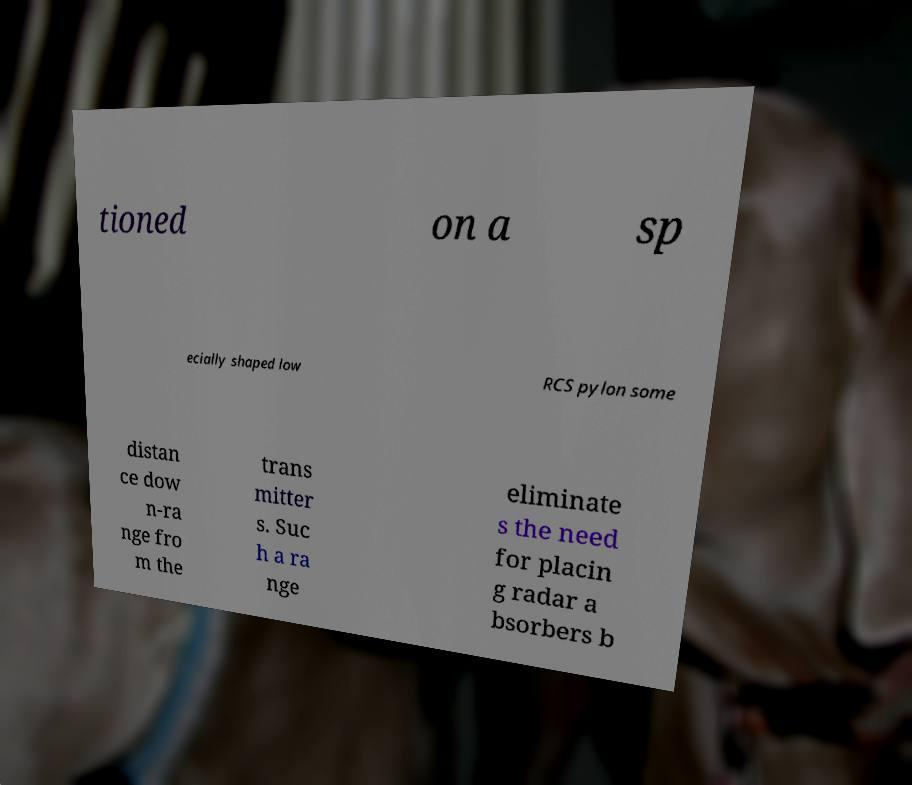What messages or text are displayed in this image? I need them in a readable, typed format. tioned on a sp ecially shaped low RCS pylon some distan ce dow n-ra nge fro m the trans mitter s. Suc h a ra nge eliminate s the need for placin g radar a bsorbers b 